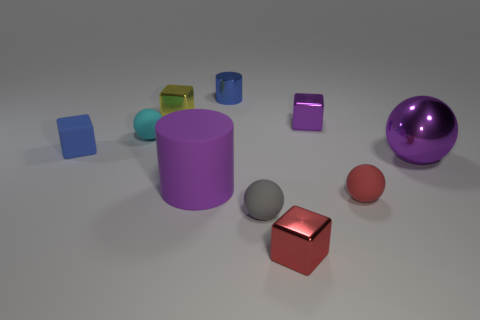There is a tiny blue thing that is right of the sphere to the left of the tiny yellow object; what is its shape? The tiny blue object to the right of the sphere and left of the tiny yellow object is a cylinder. It appears to be a smaller representation of the larger purple cylinder on the right, perhaps an item meant to mimic or complement its larger counterpart. 